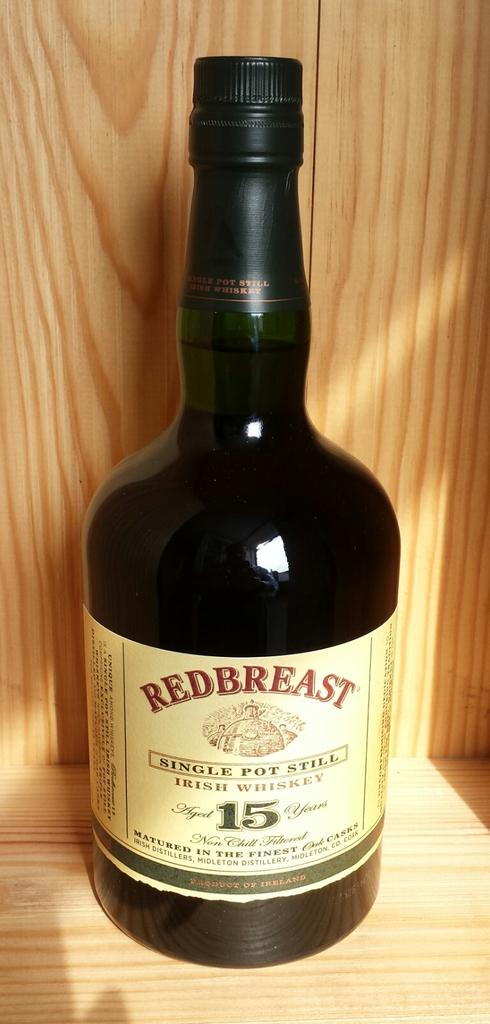<image>
Offer a succinct explanation of the picture presented. A dark colored glass bottle of Redbreast Irish whiskey with tan label and red and green text 